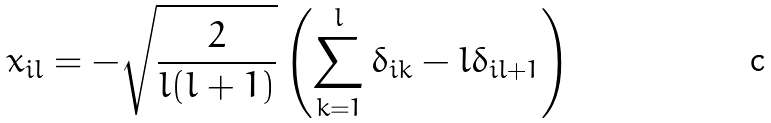Convert formula to latex. <formula><loc_0><loc_0><loc_500><loc_500>x _ { i l } = - \sqrt { \frac { 2 } { l ( l + 1 ) } } \left ( \sum _ { k = 1 } ^ { l } \delta _ { i k } - l \delta _ { i l + 1 } \right )</formula> 